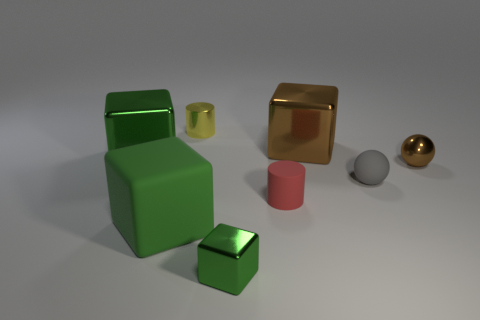Subtract all red cylinders. How many green blocks are left? 3 Subtract 1 cubes. How many cubes are left? 3 Add 2 small brown blocks. How many objects exist? 10 Subtract all cylinders. How many objects are left? 6 Subtract all rubber cylinders. Subtract all brown shiny cubes. How many objects are left? 6 Add 4 green rubber blocks. How many green rubber blocks are left? 5 Add 7 small yellow matte cylinders. How many small yellow matte cylinders exist? 7 Subtract 0 green cylinders. How many objects are left? 8 